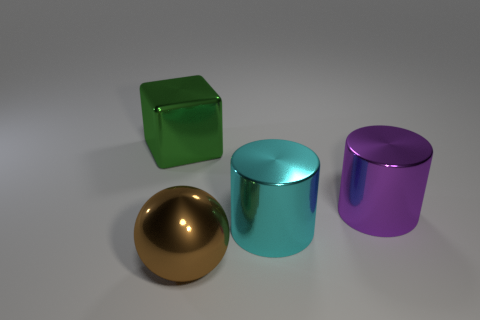There is a shiny cylinder that is behind the cyan cylinder; is its size the same as the big brown sphere?
Ensure brevity in your answer.  Yes. There is a metallic block that is the same size as the purple metal cylinder; what color is it?
Give a very brief answer. Green. There is a big block; what number of shiny cylinders are behind it?
Your response must be concise. 0. Is there a purple cube?
Ensure brevity in your answer.  No. How many other objects are the same size as the brown shiny object?
Your answer should be very brief. 3. Is there any other thing that has the same color as the block?
Your response must be concise. No. Is the object left of the brown thing made of the same material as the large cyan cylinder?
Make the answer very short. Yes. How many big shiny things are both on the right side of the ball and in front of the large purple cylinder?
Offer a very short reply. 1. What size is the thing that is behind the cylinder behind the big cyan metal cylinder?
Offer a very short reply. Large. Are there more large blue blocks than large metal cylinders?
Offer a terse response. No. 